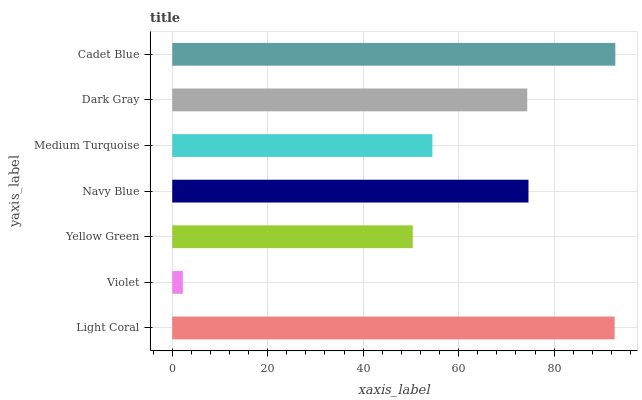Is Violet the minimum?
Answer yes or no. Yes. Is Cadet Blue the maximum?
Answer yes or no. Yes. Is Yellow Green the minimum?
Answer yes or no. No. Is Yellow Green the maximum?
Answer yes or no. No. Is Yellow Green greater than Violet?
Answer yes or no. Yes. Is Violet less than Yellow Green?
Answer yes or no. Yes. Is Violet greater than Yellow Green?
Answer yes or no. No. Is Yellow Green less than Violet?
Answer yes or no. No. Is Dark Gray the high median?
Answer yes or no. Yes. Is Dark Gray the low median?
Answer yes or no. Yes. Is Cadet Blue the high median?
Answer yes or no. No. Is Navy Blue the low median?
Answer yes or no. No. 